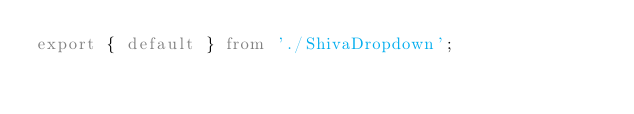<code> <loc_0><loc_0><loc_500><loc_500><_TypeScript_>export { default } from './ShivaDropdown';
</code> 